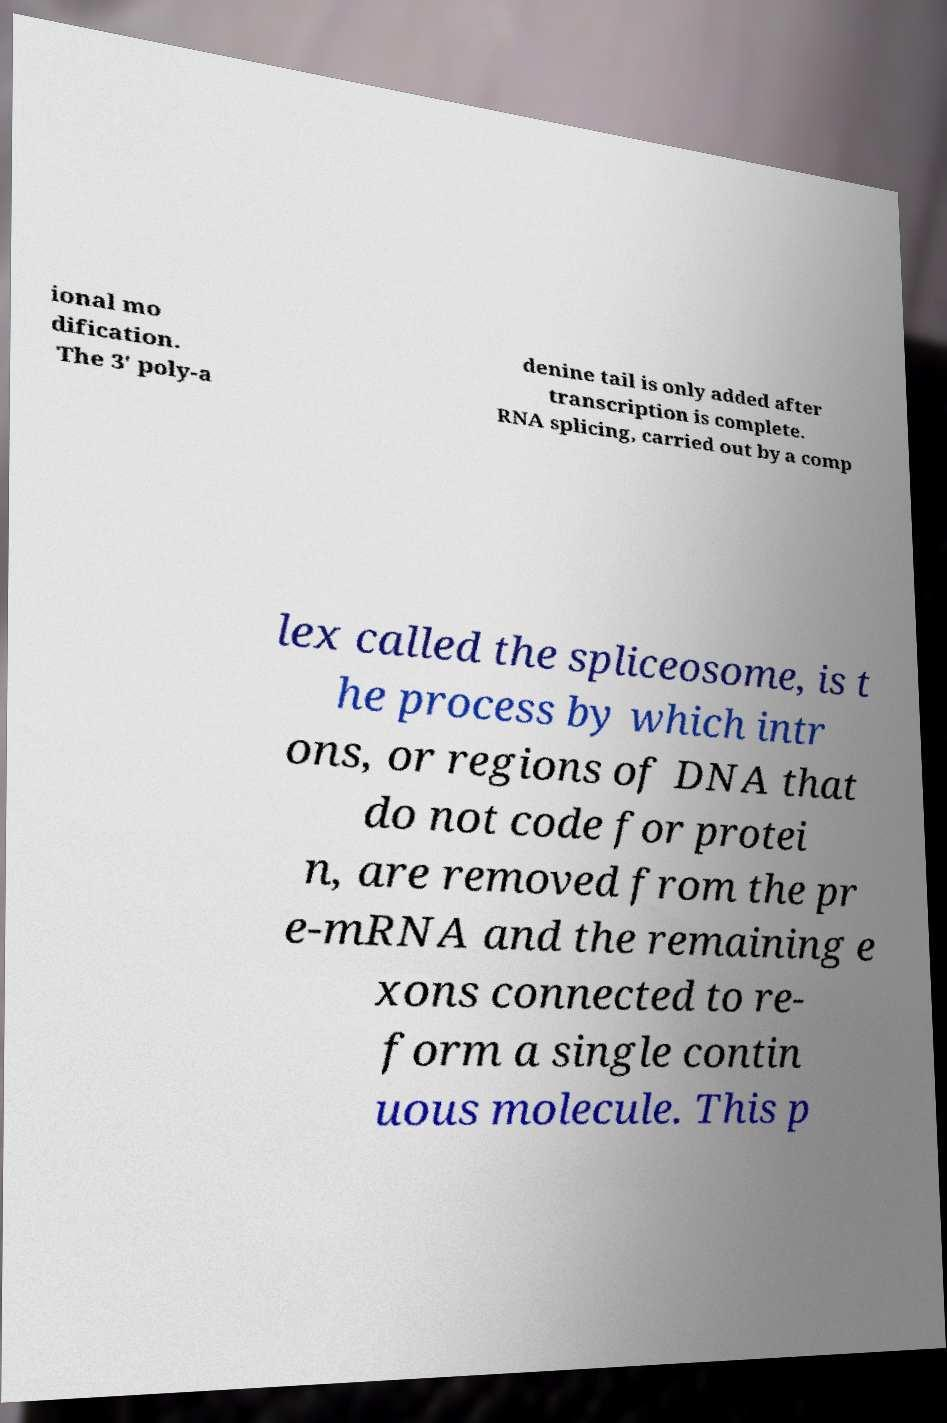I need the written content from this picture converted into text. Can you do that? ional mo dification. The 3' poly-a denine tail is only added after transcription is complete. RNA splicing, carried out by a comp lex called the spliceosome, is t he process by which intr ons, or regions of DNA that do not code for protei n, are removed from the pr e-mRNA and the remaining e xons connected to re- form a single contin uous molecule. This p 